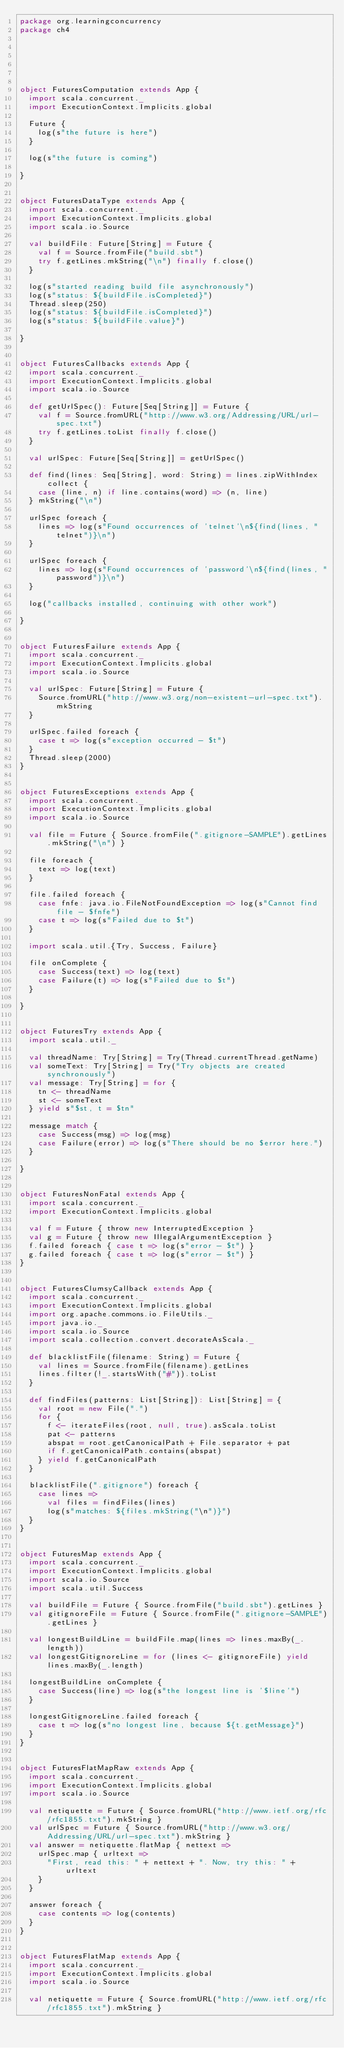<code> <loc_0><loc_0><loc_500><loc_500><_Scala_>package org.learningconcurrency
package ch4






object FuturesComputation extends App {
  import scala.concurrent._
  import ExecutionContext.Implicits.global

  Future {
    log(s"the future is here")
  }

  log(s"the future is coming")

}


object FuturesDataType extends App {
  import scala.concurrent._
  import ExecutionContext.Implicits.global
  import scala.io.Source

  val buildFile: Future[String] = Future {
    val f = Source.fromFile("build.sbt")
    try f.getLines.mkString("\n") finally f.close()
  }

  log(s"started reading build file asynchronously")
  log(s"status: ${buildFile.isCompleted}")
  Thread.sleep(250)
  log(s"status: ${buildFile.isCompleted}")
  log(s"status: ${buildFile.value}")

}


object FuturesCallbacks extends App {
  import scala.concurrent._
  import ExecutionContext.Implicits.global
  import scala.io.Source

  def getUrlSpec(): Future[Seq[String]] = Future {
    val f = Source.fromURL("http://www.w3.org/Addressing/URL/url-spec.txt")
    try f.getLines.toList finally f.close()
  }

  val urlSpec: Future[Seq[String]] = getUrlSpec()

  def find(lines: Seq[String], word: String) = lines.zipWithIndex collect {
    case (line, n) if line.contains(word) => (n, line)
  } mkString("\n")

  urlSpec foreach {
    lines => log(s"Found occurrences of 'telnet'\n${find(lines, "telnet")}\n")
  }

  urlSpec foreach {
    lines => log(s"Found occurrences of 'password'\n${find(lines, "password")}\n")
  }

  log("callbacks installed, continuing with other work")

}


object FuturesFailure extends App {
  import scala.concurrent._
  import ExecutionContext.Implicits.global
  import scala.io.Source

  val urlSpec: Future[String] = Future {
    Source.fromURL("http://www.w3.org/non-existent-url-spec.txt").mkString
  }

  urlSpec.failed foreach {
    case t => log(s"exception occurred - $t")
  }
  Thread.sleep(2000)
}


object FuturesExceptions extends App {
  import scala.concurrent._
  import ExecutionContext.Implicits.global
  import scala.io.Source

  val file = Future { Source.fromFile(".gitignore-SAMPLE").getLines.mkString("\n") }

  file foreach {
    text => log(text)
  }

  file.failed foreach {
    case fnfe: java.io.FileNotFoundException => log(s"Cannot find file - $fnfe")
    case t => log(s"Failed due to $t")
  }

  import scala.util.{Try, Success, Failure}

  file onComplete {
    case Success(text) => log(text)
    case Failure(t) => log(s"Failed due to $t")
  }

}


object FuturesTry extends App {
  import scala.util._

  val threadName: Try[String] = Try(Thread.currentThread.getName)
  val someText: Try[String] = Try("Try objects are created synchronously")
  val message: Try[String] = for {
    tn <- threadName
    st <- someText
  } yield s"$st, t = $tn"

  message match {
    case Success(msg) => log(msg)
    case Failure(error) => log(s"There should be no $error here.")
  }

}


object FuturesNonFatal extends App {
  import scala.concurrent._
  import ExecutionContext.Implicits.global

  val f = Future { throw new InterruptedException }
  val g = Future { throw new IllegalArgumentException }
  f.failed foreach { case t => log(s"error - $t") }
  g.failed foreach { case t => log(s"error - $t") }
}


object FuturesClumsyCallback extends App {
  import scala.concurrent._
  import ExecutionContext.Implicits.global
  import org.apache.commons.io.FileUtils._
  import java.io._
  import scala.io.Source
  import scala.collection.convert.decorateAsScala._

  def blacklistFile(filename: String) = Future {
    val lines = Source.fromFile(filename).getLines
    lines.filter(!_.startsWith("#")).toList
  }
  
  def findFiles(patterns: List[String]): List[String] = {
    val root = new File(".")
    for {
      f <- iterateFiles(root, null, true).asScala.toList
      pat <- patterns
      abspat = root.getCanonicalPath + File.separator + pat
      if f.getCanonicalPath.contains(abspat)
    } yield f.getCanonicalPath
  }

  blacklistFile(".gitignore") foreach {
    case lines =>
      val files = findFiles(lines)
      log(s"matches: ${files.mkString("\n")}")
  }
}


object FuturesMap extends App {
  import scala.concurrent._
  import ExecutionContext.Implicits.global
  import scala.io.Source
  import scala.util.Success

  val buildFile = Future { Source.fromFile("build.sbt").getLines }
  val gitignoreFile = Future { Source.fromFile(".gitignore-SAMPLE").getLines }

  val longestBuildLine = buildFile.map(lines => lines.maxBy(_.length))
  val longestGitignoreLine = for (lines <- gitignoreFile) yield lines.maxBy(_.length)

  longestBuildLine onComplete {
    case Success(line) => log(s"the longest line is '$line'")
  }

  longestGitignoreLine.failed foreach {
    case t => log(s"no longest line, because ${t.getMessage}")
  }
}


object FuturesFlatMapRaw extends App {
  import scala.concurrent._
  import ExecutionContext.Implicits.global
  import scala.io.Source

  val netiquette = Future { Source.fromURL("http://www.ietf.org/rfc/rfc1855.txt").mkString }
  val urlSpec = Future { Source.fromURL("http://www.w3.org/Addressing/URL/url-spec.txt").mkString }
  val answer = netiquette.flatMap { nettext =>
    urlSpec.map { urltext =>
      "First, read this: " + nettext + ". Now, try this: " + urltext
    }
  }

  answer foreach {
    case contents => log(contents)
  }
}


object FuturesFlatMap extends App {
  import scala.concurrent._
  import ExecutionContext.Implicits.global
  import scala.io.Source

  val netiquette = Future { Source.fromURL("http://www.ietf.org/rfc/rfc1855.txt").mkString }</code> 